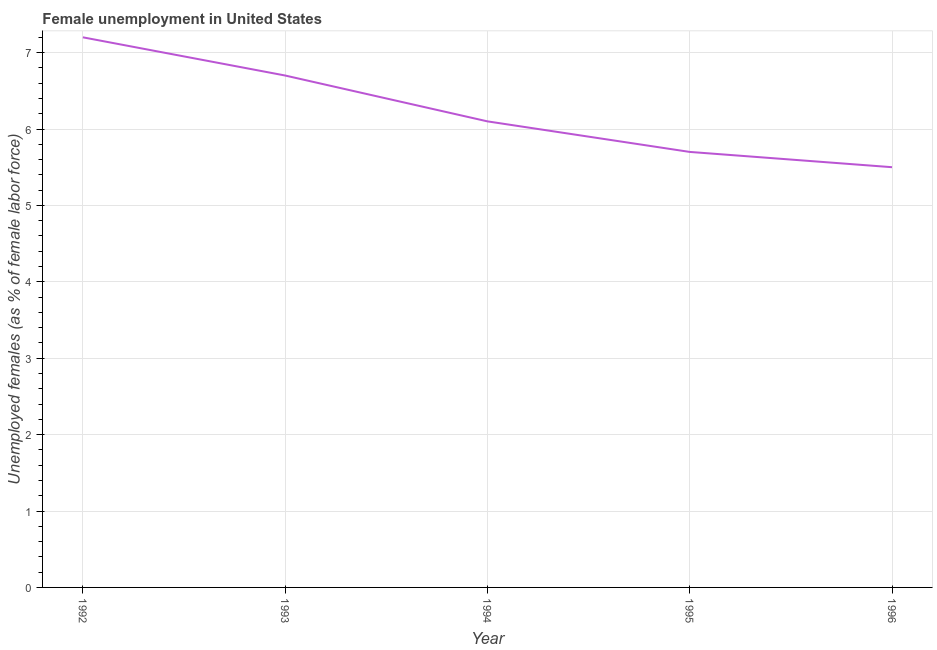What is the unemployed females population in 1995?
Your answer should be compact. 5.7. Across all years, what is the maximum unemployed females population?
Provide a short and direct response. 7.2. Across all years, what is the minimum unemployed females population?
Make the answer very short. 5.5. In which year was the unemployed females population minimum?
Keep it short and to the point. 1996. What is the sum of the unemployed females population?
Provide a short and direct response. 31.2. What is the difference between the unemployed females population in 1992 and 1994?
Keep it short and to the point. 1.1. What is the average unemployed females population per year?
Offer a very short reply. 6.24. What is the median unemployed females population?
Your response must be concise. 6.1. What is the ratio of the unemployed females population in 1992 to that in 1994?
Your response must be concise. 1.18. What is the difference between the highest and the lowest unemployed females population?
Offer a very short reply. 1.7. Does the unemployed females population monotonically increase over the years?
Offer a very short reply. No. How many years are there in the graph?
Provide a succinct answer. 5. Does the graph contain any zero values?
Your answer should be compact. No. Does the graph contain grids?
Your answer should be compact. Yes. What is the title of the graph?
Your response must be concise. Female unemployment in United States. What is the label or title of the X-axis?
Provide a succinct answer. Year. What is the label or title of the Y-axis?
Provide a short and direct response. Unemployed females (as % of female labor force). What is the Unemployed females (as % of female labor force) of 1992?
Give a very brief answer. 7.2. What is the Unemployed females (as % of female labor force) of 1993?
Offer a very short reply. 6.7. What is the Unemployed females (as % of female labor force) of 1994?
Your response must be concise. 6.1. What is the Unemployed females (as % of female labor force) of 1995?
Offer a very short reply. 5.7. What is the Unemployed females (as % of female labor force) of 1996?
Keep it short and to the point. 5.5. What is the difference between the Unemployed females (as % of female labor force) in 1992 and 1993?
Make the answer very short. 0.5. What is the difference between the Unemployed females (as % of female labor force) in 1992 and 1995?
Provide a short and direct response. 1.5. What is the difference between the Unemployed females (as % of female labor force) in 1992 and 1996?
Offer a very short reply. 1.7. What is the difference between the Unemployed females (as % of female labor force) in 1993 and 1994?
Keep it short and to the point. 0.6. What is the difference between the Unemployed females (as % of female labor force) in 1993 and 1995?
Offer a terse response. 1. What is the difference between the Unemployed females (as % of female labor force) in 1993 and 1996?
Keep it short and to the point. 1.2. What is the difference between the Unemployed females (as % of female labor force) in 1994 and 1995?
Your answer should be very brief. 0.4. What is the difference between the Unemployed females (as % of female labor force) in 1994 and 1996?
Your answer should be compact. 0.6. What is the ratio of the Unemployed females (as % of female labor force) in 1992 to that in 1993?
Your response must be concise. 1.07. What is the ratio of the Unemployed females (as % of female labor force) in 1992 to that in 1994?
Your answer should be very brief. 1.18. What is the ratio of the Unemployed females (as % of female labor force) in 1992 to that in 1995?
Your answer should be very brief. 1.26. What is the ratio of the Unemployed females (as % of female labor force) in 1992 to that in 1996?
Give a very brief answer. 1.31. What is the ratio of the Unemployed females (as % of female labor force) in 1993 to that in 1994?
Make the answer very short. 1.1. What is the ratio of the Unemployed females (as % of female labor force) in 1993 to that in 1995?
Your response must be concise. 1.18. What is the ratio of the Unemployed females (as % of female labor force) in 1993 to that in 1996?
Your answer should be compact. 1.22. What is the ratio of the Unemployed females (as % of female labor force) in 1994 to that in 1995?
Your answer should be compact. 1.07. What is the ratio of the Unemployed females (as % of female labor force) in 1994 to that in 1996?
Keep it short and to the point. 1.11. What is the ratio of the Unemployed females (as % of female labor force) in 1995 to that in 1996?
Provide a short and direct response. 1.04. 